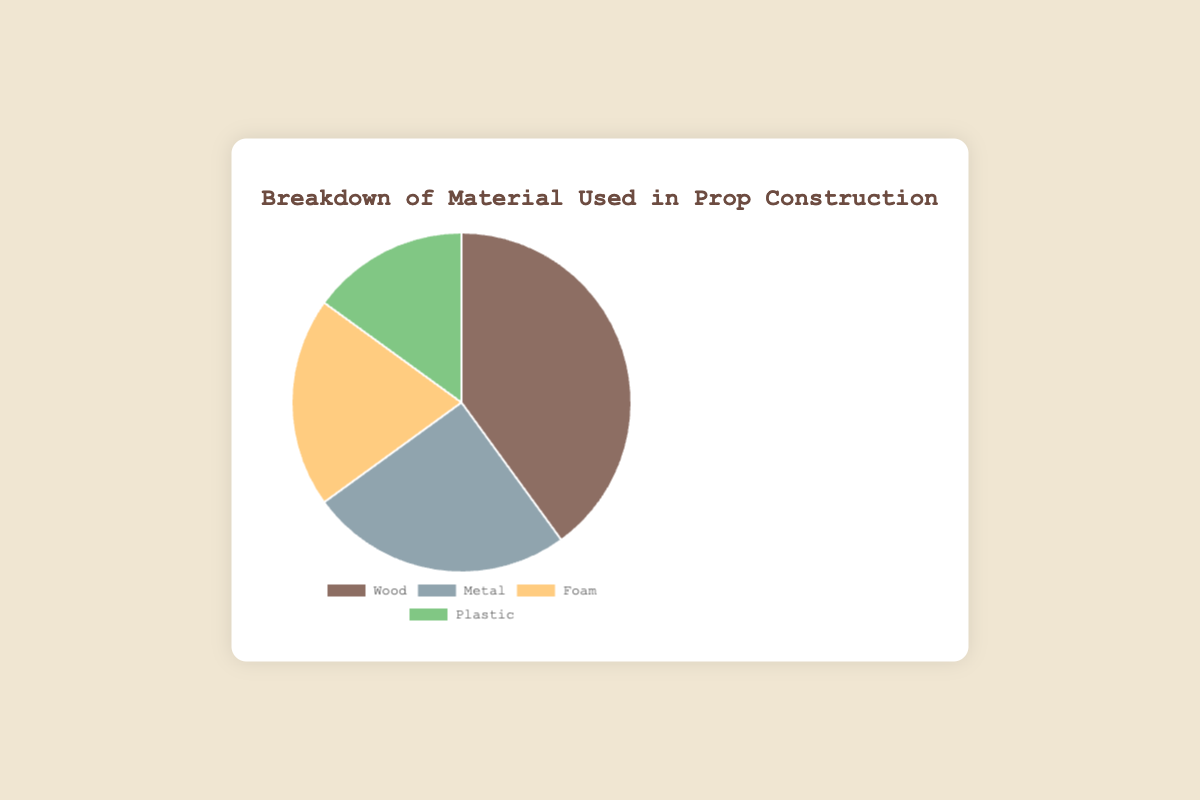What percentage of the materials used in prop construction is plastic? The pie chart shows that plastic accounts for 15% of the total materials used in prop construction.
Answer: 15% Which material has the highest usage percentage in prop construction? The largest section of the pie chart is wood, which shows it has the highest usage percentage at 40%.
Answer: Wood What is the difference in usage percentages between wood and metal? The pie chart indicates that wood is used 40% of the time and metal 25%. The difference is 40% - 25% = 15%.
Answer: 15% How much more frequently is foam used compared to plastic? Foam is used for 20% of the materials, while plastic is used for 15%. The difference in usage is 20% - 15% = 5%.
Answer: 5% What percentage of the materials used in prop construction are either foam or plastic? The pie chart shows foam at 20% and plastic at 15%. Adding these together gives 20% + 15% = 35%.
Answer: 35% Which material accounts for a quarter of the total materials used? The pie chart shows that metal accounts for 25%, which is a quarter of the total materials.
Answer: Metal Is the usage of metal higher or lower than the combined usage of foam and plastic? The pie chart shows metal at 25%, foam at 20%, and plastic at 15%. The combined usage of foam and plastic is 20% + 15% = 35%. Since 25% is less than 35%, metal usage is lower.
Answer: Lower What is the sum of usage percentages for all materials used in prop construction? According to the pie chart, the usage percentages for wood, metal, foam, and plastic are 40%, 25%, 20%, and 15%, respectively. Adding these together gives 40% + 25% + 20% + 15% = 100%.
Answer: 100% Which color represents the material with the second-highest usage percentage? The pie chart indicates that metal, which is used 25% of the time, is the second-highest. The color representing metal is gray.
Answer: Gray 